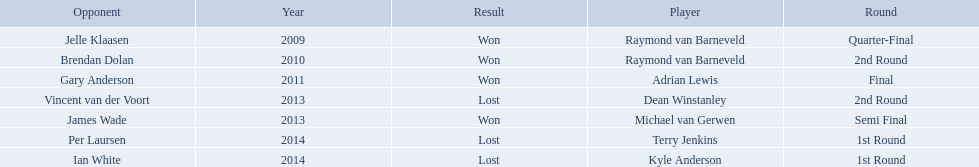Did terry jenkins win in 2014? Terry Jenkins, Lost. If terry jenkins lost who won? Per Laursen. Who are the players at the pdc world darts championship? Raymond van Barneveld, Raymond van Barneveld, Adrian Lewis, Dean Winstanley, Michael van Gerwen, Terry Jenkins, Kyle Anderson. When did kyle anderson lose? 2014. Which other players lost in 2014? Terry Jenkins. 